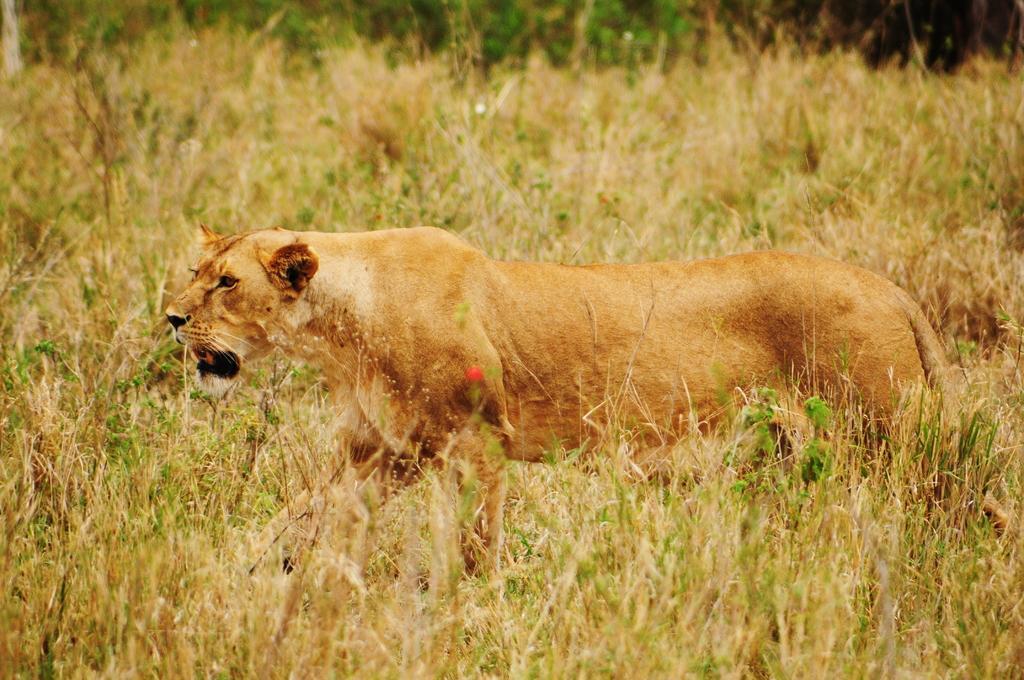Can you describe this image briefly? In this picture we can see an animal on the ground and in the background we can see plants. 